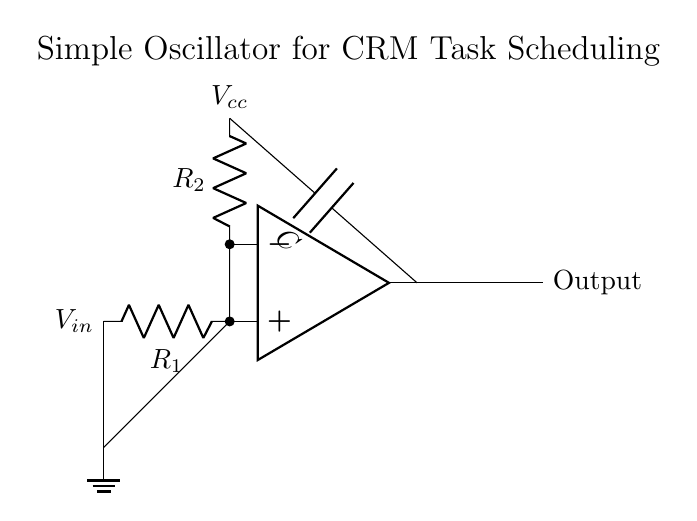What is the type of this circuit? The circuit is an oscillator circuit, which is used to generate periodic signals. This can be inferred from the presence of feedback components (resistors and capacitors) that indicate it is designed to create oscillations.
Answer: oscillator What are the components shown in the circuit? The components in the circuit are an operational amplifier, two resistors, and one capacitor. Each of these elements can be identified by their labels and symbols in the circuit diagram.
Answer: operational amplifier, resistors, capacitor What is the role of the capacitor in this circuit? The capacitor is used for timing and to determine the frequency of oscillation. In oscillator circuits, the capacitor charges and discharges, contributing to the periodic signal generation, which is critical for scheduling tasks in a CRM system.
Answer: timing What is the function of resistor R1 in this circuit? Resistor R1 is part of the feedback loop of the oscillator, which helps determine the gain and frequency of oscillation. Its position connected to the output of the op-amp indicates that it plays a crucial role in maintaining the oscillation.
Answer: feedback How many resistors are in the circuit? The circuit contains two resistors. Each resistor is explicitly labeled in the diagram, making it clear how many are present and their connections.
Answer: two What is the voltage supply of this oscillator circuit? The voltage supply labeled in the circuit diagram is Vcc, which represents the positive power supply voltage needed for the operational amplifier to function correctly. The exact value is not provided, but it is critical for the operation of the circuit.
Answer: Vcc What does the output of the circuit represent? The output of the circuit represents the timing signal generated by the oscillator. This output is essential for automated tasks in a CRM system, as it provides the regular timing needed for scheduling.
Answer: timing signal 